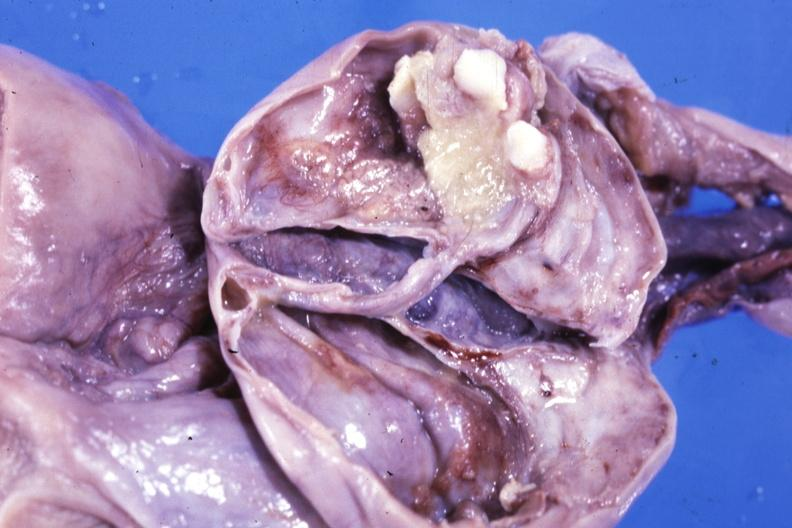what opened ovarian cyst with two or three teeth?
Answer the question using a single word or phrase. Fixed tissue 